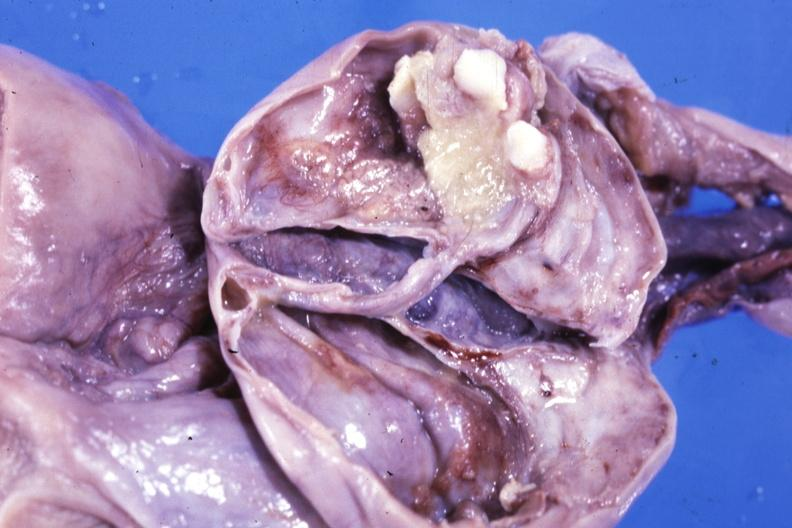what opened ovarian cyst with two or three teeth?
Answer the question using a single word or phrase. Fixed tissue 